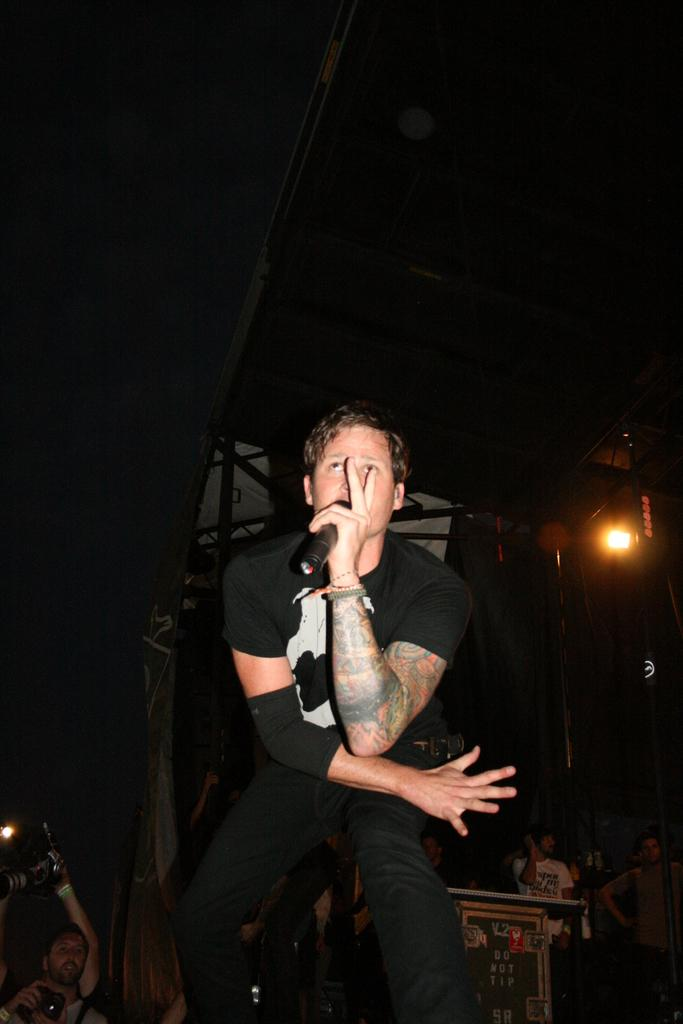What is the main subject of the image? The main subject of the image is a man. What is the man doing in the image? The man is sitting in a chair and holding a microphone. What can be seen in the background of the image? There are lights and a group of people standing in the background of the image. What type of game is being played in the image? There is no game being played in the image; it features a man sitting in a chair holding a microphone. Can you see any leaves in the image? There are no leaves visible in the image. 